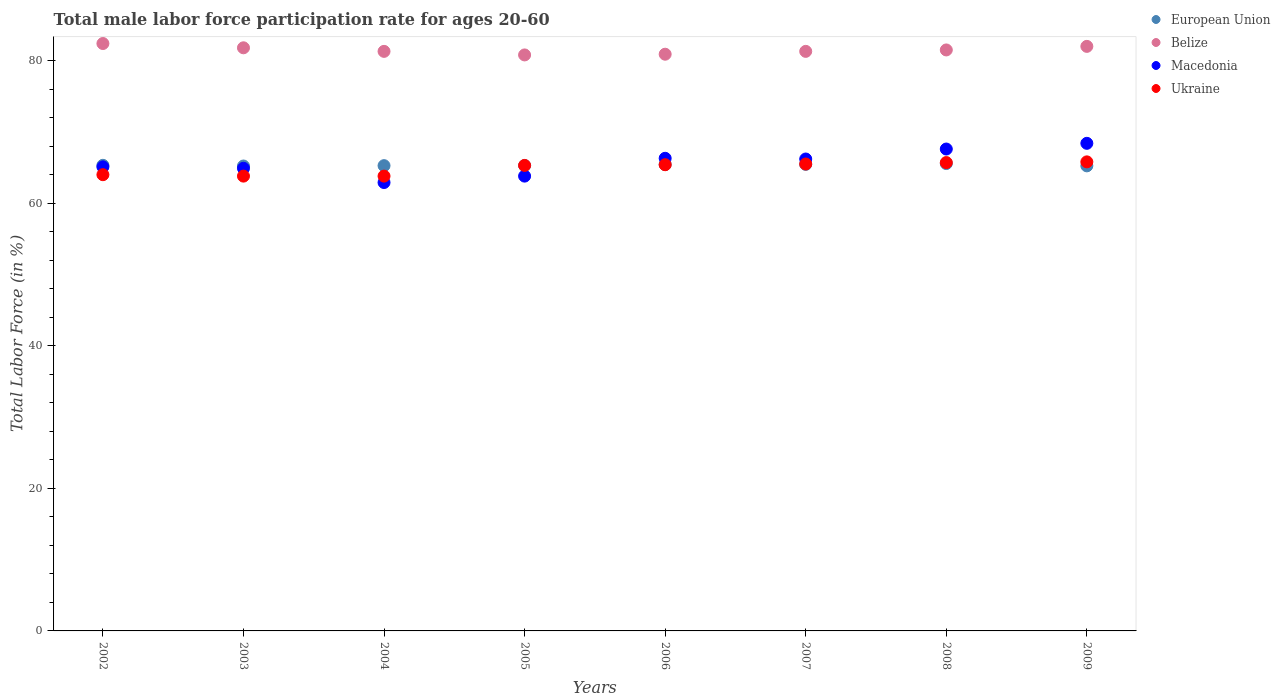How many different coloured dotlines are there?
Ensure brevity in your answer.  4. Is the number of dotlines equal to the number of legend labels?
Provide a succinct answer. Yes. What is the male labor force participation rate in Ukraine in 2007?
Your answer should be compact. 65.5. Across all years, what is the maximum male labor force participation rate in European Union?
Ensure brevity in your answer.  65.56. Across all years, what is the minimum male labor force participation rate in European Union?
Offer a terse response. 65.22. In which year was the male labor force participation rate in Ukraine maximum?
Provide a succinct answer. 2009. What is the total male labor force participation rate in Belize in the graph?
Provide a succinct answer. 652. What is the difference between the male labor force participation rate in European Union in 2002 and that in 2006?
Your answer should be compact. -0.1. What is the difference between the male labor force participation rate in Belize in 2004 and the male labor force participation rate in European Union in 2008?
Offer a very short reply. 15.74. What is the average male labor force participation rate in European Union per year?
Your answer should be compact. 65.34. In the year 2003, what is the difference between the male labor force participation rate in Macedonia and male labor force participation rate in Ukraine?
Your answer should be compact. 1.1. In how many years, is the male labor force participation rate in Macedonia greater than 8 %?
Keep it short and to the point. 8. What is the ratio of the male labor force participation rate in European Union in 2007 to that in 2008?
Ensure brevity in your answer.  1. Is the male labor force participation rate in Macedonia in 2006 less than that in 2008?
Make the answer very short. Yes. What is the difference between the highest and the second highest male labor force participation rate in Belize?
Your response must be concise. 0.4. What is the difference between the highest and the lowest male labor force participation rate in Ukraine?
Make the answer very short. 2. Is the sum of the male labor force participation rate in Ukraine in 2007 and 2009 greater than the maximum male labor force participation rate in Macedonia across all years?
Keep it short and to the point. Yes. Is it the case that in every year, the sum of the male labor force participation rate in European Union and male labor force participation rate in Belize  is greater than the sum of male labor force participation rate in Macedonia and male labor force participation rate in Ukraine?
Offer a terse response. Yes. Does the male labor force participation rate in Ukraine monotonically increase over the years?
Your response must be concise. No. How many dotlines are there?
Your answer should be very brief. 4. What is the difference between two consecutive major ticks on the Y-axis?
Provide a short and direct response. 20. Are the values on the major ticks of Y-axis written in scientific E-notation?
Your answer should be very brief. No. Does the graph contain any zero values?
Your answer should be very brief. No. Does the graph contain grids?
Your response must be concise. No. Where does the legend appear in the graph?
Your answer should be very brief. Top right. What is the title of the graph?
Offer a very short reply. Total male labor force participation rate for ages 20-60. Does "Arab World" appear as one of the legend labels in the graph?
Your response must be concise. No. What is the Total Labor Force (in %) of European Union in 2002?
Keep it short and to the point. 65.31. What is the Total Labor Force (in %) of Belize in 2002?
Make the answer very short. 82.4. What is the Total Labor Force (in %) of Macedonia in 2002?
Make the answer very short. 65.1. What is the Total Labor Force (in %) in Ukraine in 2002?
Make the answer very short. 64. What is the Total Labor Force (in %) of European Union in 2003?
Ensure brevity in your answer.  65.22. What is the Total Labor Force (in %) of Belize in 2003?
Provide a succinct answer. 81.8. What is the Total Labor Force (in %) of Macedonia in 2003?
Offer a very short reply. 64.9. What is the Total Labor Force (in %) in Ukraine in 2003?
Offer a very short reply. 63.8. What is the Total Labor Force (in %) of European Union in 2004?
Provide a short and direct response. 65.27. What is the Total Labor Force (in %) of Belize in 2004?
Offer a very short reply. 81.3. What is the Total Labor Force (in %) of Macedonia in 2004?
Your answer should be very brief. 62.9. What is the Total Labor Force (in %) of Ukraine in 2004?
Your answer should be very brief. 63.8. What is the Total Labor Force (in %) of European Union in 2005?
Offer a terse response. 65.28. What is the Total Labor Force (in %) of Belize in 2005?
Give a very brief answer. 80.8. What is the Total Labor Force (in %) of Macedonia in 2005?
Offer a very short reply. 63.8. What is the Total Labor Force (in %) in Ukraine in 2005?
Make the answer very short. 65.3. What is the Total Labor Force (in %) of European Union in 2006?
Ensure brevity in your answer.  65.42. What is the Total Labor Force (in %) of Belize in 2006?
Provide a succinct answer. 80.9. What is the Total Labor Force (in %) in Macedonia in 2006?
Offer a terse response. 66.3. What is the Total Labor Force (in %) of Ukraine in 2006?
Your answer should be compact. 65.4. What is the Total Labor Force (in %) in European Union in 2007?
Provide a succinct answer. 65.45. What is the Total Labor Force (in %) of Belize in 2007?
Your answer should be compact. 81.3. What is the Total Labor Force (in %) in Macedonia in 2007?
Provide a short and direct response. 66.2. What is the Total Labor Force (in %) of Ukraine in 2007?
Provide a short and direct response. 65.5. What is the Total Labor Force (in %) in European Union in 2008?
Ensure brevity in your answer.  65.56. What is the Total Labor Force (in %) in Belize in 2008?
Make the answer very short. 81.5. What is the Total Labor Force (in %) of Macedonia in 2008?
Make the answer very short. 67.6. What is the Total Labor Force (in %) of Ukraine in 2008?
Give a very brief answer. 65.7. What is the Total Labor Force (in %) in European Union in 2009?
Keep it short and to the point. 65.24. What is the Total Labor Force (in %) of Macedonia in 2009?
Your answer should be very brief. 68.4. What is the Total Labor Force (in %) in Ukraine in 2009?
Give a very brief answer. 65.8. Across all years, what is the maximum Total Labor Force (in %) in European Union?
Provide a short and direct response. 65.56. Across all years, what is the maximum Total Labor Force (in %) of Belize?
Your answer should be compact. 82.4. Across all years, what is the maximum Total Labor Force (in %) of Macedonia?
Give a very brief answer. 68.4. Across all years, what is the maximum Total Labor Force (in %) in Ukraine?
Provide a short and direct response. 65.8. Across all years, what is the minimum Total Labor Force (in %) of European Union?
Provide a succinct answer. 65.22. Across all years, what is the minimum Total Labor Force (in %) of Belize?
Make the answer very short. 80.8. Across all years, what is the minimum Total Labor Force (in %) in Macedonia?
Offer a terse response. 62.9. Across all years, what is the minimum Total Labor Force (in %) in Ukraine?
Give a very brief answer. 63.8. What is the total Total Labor Force (in %) in European Union in the graph?
Keep it short and to the point. 522.75. What is the total Total Labor Force (in %) in Belize in the graph?
Your answer should be very brief. 652. What is the total Total Labor Force (in %) in Macedonia in the graph?
Offer a terse response. 525.2. What is the total Total Labor Force (in %) in Ukraine in the graph?
Your answer should be very brief. 519.3. What is the difference between the Total Labor Force (in %) of European Union in 2002 and that in 2003?
Give a very brief answer. 0.1. What is the difference between the Total Labor Force (in %) in Belize in 2002 and that in 2003?
Your response must be concise. 0.6. What is the difference between the Total Labor Force (in %) of European Union in 2002 and that in 2004?
Ensure brevity in your answer.  0.05. What is the difference between the Total Labor Force (in %) in Macedonia in 2002 and that in 2004?
Offer a terse response. 2.2. What is the difference between the Total Labor Force (in %) in European Union in 2002 and that in 2005?
Offer a very short reply. 0.03. What is the difference between the Total Labor Force (in %) in Macedonia in 2002 and that in 2005?
Offer a terse response. 1.3. What is the difference between the Total Labor Force (in %) in Ukraine in 2002 and that in 2005?
Offer a very short reply. -1.3. What is the difference between the Total Labor Force (in %) in European Union in 2002 and that in 2006?
Provide a succinct answer. -0.1. What is the difference between the Total Labor Force (in %) in Belize in 2002 and that in 2006?
Your answer should be compact. 1.5. What is the difference between the Total Labor Force (in %) in Macedonia in 2002 and that in 2006?
Offer a very short reply. -1.2. What is the difference between the Total Labor Force (in %) in European Union in 2002 and that in 2007?
Offer a very short reply. -0.13. What is the difference between the Total Labor Force (in %) in Belize in 2002 and that in 2007?
Offer a terse response. 1.1. What is the difference between the Total Labor Force (in %) of Ukraine in 2002 and that in 2007?
Keep it short and to the point. -1.5. What is the difference between the Total Labor Force (in %) of European Union in 2002 and that in 2008?
Keep it short and to the point. -0.25. What is the difference between the Total Labor Force (in %) of Belize in 2002 and that in 2008?
Provide a short and direct response. 0.9. What is the difference between the Total Labor Force (in %) in Macedonia in 2002 and that in 2008?
Provide a short and direct response. -2.5. What is the difference between the Total Labor Force (in %) of Ukraine in 2002 and that in 2008?
Provide a succinct answer. -1.7. What is the difference between the Total Labor Force (in %) of European Union in 2002 and that in 2009?
Give a very brief answer. 0.08. What is the difference between the Total Labor Force (in %) in Belize in 2002 and that in 2009?
Provide a short and direct response. 0.4. What is the difference between the Total Labor Force (in %) in European Union in 2003 and that in 2004?
Provide a succinct answer. -0.05. What is the difference between the Total Labor Force (in %) of Belize in 2003 and that in 2004?
Keep it short and to the point. 0.5. What is the difference between the Total Labor Force (in %) in Macedonia in 2003 and that in 2004?
Keep it short and to the point. 2. What is the difference between the Total Labor Force (in %) in Ukraine in 2003 and that in 2004?
Ensure brevity in your answer.  0. What is the difference between the Total Labor Force (in %) of European Union in 2003 and that in 2005?
Keep it short and to the point. -0.06. What is the difference between the Total Labor Force (in %) in Ukraine in 2003 and that in 2005?
Your response must be concise. -1.5. What is the difference between the Total Labor Force (in %) of European Union in 2003 and that in 2006?
Give a very brief answer. -0.2. What is the difference between the Total Labor Force (in %) of Belize in 2003 and that in 2006?
Provide a succinct answer. 0.9. What is the difference between the Total Labor Force (in %) in Macedonia in 2003 and that in 2006?
Provide a succinct answer. -1.4. What is the difference between the Total Labor Force (in %) of European Union in 2003 and that in 2007?
Keep it short and to the point. -0.23. What is the difference between the Total Labor Force (in %) in Macedonia in 2003 and that in 2007?
Your answer should be very brief. -1.3. What is the difference between the Total Labor Force (in %) in Ukraine in 2003 and that in 2007?
Your answer should be very brief. -1.7. What is the difference between the Total Labor Force (in %) in European Union in 2003 and that in 2008?
Provide a short and direct response. -0.34. What is the difference between the Total Labor Force (in %) of Macedonia in 2003 and that in 2008?
Keep it short and to the point. -2.7. What is the difference between the Total Labor Force (in %) in Ukraine in 2003 and that in 2008?
Your answer should be very brief. -1.9. What is the difference between the Total Labor Force (in %) in European Union in 2003 and that in 2009?
Offer a very short reply. -0.02. What is the difference between the Total Labor Force (in %) of Ukraine in 2003 and that in 2009?
Make the answer very short. -2. What is the difference between the Total Labor Force (in %) of European Union in 2004 and that in 2005?
Ensure brevity in your answer.  -0.01. What is the difference between the Total Labor Force (in %) in Macedonia in 2004 and that in 2005?
Give a very brief answer. -0.9. What is the difference between the Total Labor Force (in %) of European Union in 2004 and that in 2006?
Ensure brevity in your answer.  -0.15. What is the difference between the Total Labor Force (in %) of Macedonia in 2004 and that in 2006?
Offer a very short reply. -3.4. What is the difference between the Total Labor Force (in %) in Ukraine in 2004 and that in 2006?
Offer a terse response. -1.6. What is the difference between the Total Labor Force (in %) of European Union in 2004 and that in 2007?
Keep it short and to the point. -0.18. What is the difference between the Total Labor Force (in %) in Belize in 2004 and that in 2007?
Provide a succinct answer. 0. What is the difference between the Total Labor Force (in %) of European Union in 2004 and that in 2008?
Provide a short and direct response. -0.29. What is the difference between the Total Labor Force (in %) of Belize in 2004 and that in 2008?
Ensure brevity in your answer.  -0.2. What is the difference between the Total Labor Force (in %) in European Union in 2004 and that in 2009?
Make the answer very short. 0.03. What is the difference between the Total Labor Force (in %) of Belize in 2004 and that in 2009?
Provide a short and direct response. -0.7. What is the difference between the Total Labor Force (in %) of Ukraine in 2004 and that in 2009?
Your answer should be compact. -2. What is the difference between the Total Labor Force (in %) of European Union in 2005 and that in 2006?
Offer a terse response. -0.14. What is the difference between the Total Labor Force (in %) in Belize in 2005 and that in 2006?
Your response must be concise. -0.1. What is the difference between the Total Labor Force (in %) in Macedonia in 2005 and that in 2006?
Your response must be concise. -2.5. What is the difference between the Total Labor Force (in %) in European Union in 2005 and that in 2007?
Offer a very short reply. -0.17. What is the difference between the Total Labor Force (in %) in Belize in 2005 and that in 2007?
Keep it short and to the point. -0.5. What is the difference between the Total Labor Force (in %) in European Union in 2005 and that in 2008?
Offer a very short reply. -0.28. What is the difference between the Total Labor Force (in %) in Belize in 2005 and that in 2008?
Provide a succinct answer. -0.7. What is the difference between the Total Labor Force (in %) in European Union in 2005 and that in 2009?
Give a very brief answer. 0.04. What is the difference between the Total Labor Force (in %) of Ukraine in 2005 and that in 2009?
Ensure brevity in your answer.  -0.5. What is the difference between the Total Labor Force (in %) of European Union in 2006 and that in 2007?
Keep it short and to the point. -0.03. What is the difference between the Total Labor Force (in %) in Macedonia in 2006 and that in 2007?
Offer a very short reply. 0.1. What is the difference between the Total Labor Force (in %) of European Union in 2006 and that in 2008?
Offer a terse response. -0.14. What is the difference between the Total Labor Force (in %) in Belize in 2006 and that in 2008?
Your response must be concise. -0.6. What is the difference between the Total Labor Force (in %) in Ukraine in 2006 and that in 2008?
Your answer should be compact. -0.3. What is the difference between the Total Labor Force (in %) in European Union in 2006 and that in 2009?
Ensure brevity in your answer.  0.18. What is the difference between the Total Labor Force (in %) of Belize in 2006 and that in 2009?
Provide a short and direct response. -1.1. What is the difference between the Total Labor Force (in %) of European Union in 2007 and that in 2008?
Offer a very short reply. -0.12. What is the difference between the Total Labor Force (in %) in Belize in 2007 and that in 2008?
Offer a very short reply. -0.2. What is the difference between the Total Labor Force (in %) of European Union in 2007 and that in 2009?
Provide a succinct answer. 0.21. What is the difference between the Total Labor Force (in %) in Belize in 2007 and that in 2009?
Make the answer very short. -0.7. What is the difference between the Total Labor Force (in %) of Macedonia in 2007 and that in 2009?
Offer a terse response. -2.2. What is the difference between the Total Labor Force (in %) of European Union in 2008 and that in 2009?
Your answer should be compact. 0.32. What is the difference between the Total Labor Force (in %) in Belize in 2008 and that in 2009?
Ensure brevity in your answer.  -0.5. What is the difference between the Total Labor Force (in %) of Macedonia in 2008 and that in 2009?
Ensure brevity in your answer.  -0.8. What is the difference between the Total Labor Force (in %) in Ukraine in 2008 and that in 2009?
Offer a terse response. -0.1. What is the difference between the Total Labor Force (in %) of European Union in 2002 and the Total Labor Force (in %) of Belize in 2003?
Your answer should be compact. -16.49. What is the difference between the Total Labor Force (in %) in European Union in 2002 and the Total Labor Force (in %) in Macedonia in 2003?
Keep it short and to the point. 0.41. What is the difference between the Total Labor Force (in %) in European Union in 2002 and the Total Labor Force (in %) in Ukraine in 2003?
Offer a very short reply. 1.51. What is the difference between the Total Labor Force (in %) in Belize in 2002 and the Total Labor Force (in %) in Macedonia in 2003?
Make the answer very short. 17.5. What is the difference between the Total Labor Force (in %) in Macedonia in 2002 and the Total Labor Force (in %) in Ukraine in 2003?
Provide a succinct answer. 1.3. What is the difference between the Total Labor Force (in %) of European Union in 2002 and the Total Labor Force (in %) of Belize in 2004?
Ensure brevity in your answer.  -15.99. What is the difference between the Total Labor Force (in %) in European Union in 2002 and the Total Labor Force (in %) in Macedonia in 2004?
Your answer should be very brief. 2.41. What is the difference between the Total Labor Force (in %) of European Union in 2002 and the Total Labor Force (in %) of Ukraine in 2004?
Provide a succinct answer. 1.51. What is the difference between the Total Labor Force (in %) in European Union in 2002 and the Total Labor Force (in %) in Belize in 2005?
Your response must be concise. -15.49. What is the difference between the Total Labor Force (in %) in European Union in 2002 and the Total Labor Force (in %) in Macedonia in 2005?
Give a very brief answer. 1.51. What is the difference between the Total Labor Force (in %) of European Union in 2002 and the Total Labor Force (in %) of Ukraine in 2005?
Provide a short and direct response. 0.01. What is the difference between the Total Labor Force (in %) of Belize in 2002 and the Total Labor Force (in %) of Macedonia in 2005?
Give a very brief answer. 18.6. What is the difference between the Total Labor Force (in %) of Belize in 2002 and the Total Labor Force (in %) of Ukraine in 2005?
Provide a succinct answer. 17.1. What is the difference between the Total Labor Force (in %) in European Union in 2002 and the Total Labor Force (in %) in Belize in 2006?
Offer a very short reply. -15.59. What is the difference between the Total Labor Force (in %) in European Union in 2002 and the Total Labor Force (in %) in Macedonia in 2006?
Give a very brief answer. -0.99. What is the difference between the Total Labor Force (in %) in European Union in 2002 and the Total Labor Force (in %) in Ukraine in 2006?
Make the answer very short. -0.09. What is the difference between the Total Labor Force (in %) of Belize in 2002 and the Total Labor Force (in %) of Macedonia in 2006?
Offer a terse response. 16.1. What is the difference between the Total Labor Force (in %) in Belize in 2002 and the Total Labor Force (in %) in Ukraine in 2006?
Offer a terse response. 17. What is the difference between the Total Labor Force (in %) in European Union in 2002 and the Total Labor Force (in %) in Belize in 2007?
Ensure brevity in your answer.  -15.99. What is the difference between the Total Labor Force (in %) of European Union in 2002 and the Total Labor Force (in %) of Macedonia in 2007?
Give a very brief answer. -0.89. What is the difference between the Total Labor Force (in %) of European Union in 2002 and the Total Labor Force (in %) of Ukraine in 2007?
Your answer should be very brief. -0.19. What is the difference between the Total Labor Force (in %) in Belize in 2002 and the Total Labor Force (in %) in Ukraine in 2007?
Keep it short and to the point. 16.9. What is the difference between the Total Labor Force (in %) in European Union in 2002 and the Total Labor Force (in %) in Belize in 2008?
Your response must be concise. -16.19. What is the difference between the Total Labor Force (in %) of European Union in 2002 and the Total Labor Force (in %) of Macedonia in 2008?
Make the answer very short. -2.29. What is the difference between the Total Labor Force (in %) in European Union in 2002 and the Total Labor Force (in %) in Ukraine in 2008?
Offer a terse response. -0.39. What is the difference between the Total Labor Force (in %) in European Union in 2002 and the Total Labor Force (in %) in Belize in 2009?
Make the answer very short. -16.69. What is the difference between the Total Labor Force (in %) in European Union in 2002 and the Total Labor Force (in %) in Macedonia in 2009?
Keep it short and to the point. -3.09. What is the difference between the Total Labor Force (in %) of European Union in 2002 and the Total Labor Force (in %) of Ukraine in 2009?
Offer a very short reply. -0.49. What is the difference between the Total Labor Force (in %) of Belize in 2002 and the Total Labor Force (in %) of Macedonia in 2009?
Your answer should be compact. 14. What is the difference between the Total Labor Force (in %) of Belize in 2002 and the Total Labor Force (in %) of Ukraine in 2009?
Your response must be concise. 16.6. What is the difference between the Total Labor Force (in %) of European Union in 2003 and the Total Labor Force (in %) of Belize in 2004?
Offer a terse response. -16.08. What is the difference between the Total Labor Force (in %) of European Union in 2003 and the Total Labor Force (in %) of Macedonia in 2004?
Offer a very short reply. 2.32. What is the difference between the Total Labor Force (in %) in European Union in 2003 and the Total Labor Force (in %) in Ukraine in 2004?
Make the answer very short. 1.42. What is the difference between the Total Labor Force (in %) of Belize in 2003 and the Total Labor Force (in %) of Macedonia in 2004?
Provide a short and direct response. 18.9. What is the difference between the Total Labor Force (in %) of Belize in 2003 and the Total Labor Force (in %) of Ukraine in 2004?
Your answer should be very brief. 18. What is the difference between the Total Labor Force (in %) in European Union in 2003 and the Total Labor Force (in %) in Belize in 2005?
Provide a short and direct response. -15.58. What is the difference between the Total Labor Force (in %) in European Union in 2003 and the Total Labor Force (in %) in Macedonia in 2005?
Provide a succinct answer. 1.42. What is the difference between the Total Labor Force (in %) of European Union in 2003 and the Total Labor Force (in %) of Ukraine in 2005?
Keep it short and to the point. -0.08. What is the difference between the Total Labor Force (in %) of Belize in 2003 and the Total Labor Force (in %) of Macedonia in 2005?
Offer a very short reply. 18. What is the difference between the Total Labor Force (in %) in European Union in 2003 and the Total Labor Force (in %) in Belize in 2006?
Offer a very short reply. -15.68. What is the difference between the Total Labor Force (in %) in European Union in 2003 and the Total Labor Force (in %) in Macedonia in 2006?
Provide a succinct answer. -1.08. What is the difference between the Total Labor Force (in %) in European Union in 2003 and the Total Labor Force (in %) in Ukraine in 2006?
Offer a very short reply. -0.18. What is the difference between the Total Labor Force (in %) of Belize in 2003 and the Total Labor Force (in %) of Macedonia in 2006?
Provide a succinct answer. 15.5. What is the difference between the Total Labor Force (in %) in European Union in 2003 and the Total Labor Force (in %) in Belize in 2007?
Make the answer very short. -16.08. What is the difference between the Total Labor Force (in %) in European Union in 2003 and the Total Labor Force (in %) in Macedonia in 2007?
Your answer should be very brief. -0.98. What is the difference between the Total Labor Force (in %) in European Union in 2003 and the Total Labor Force (in %) in Ukraine in 2007?
Provide a succinct answer. -0.28. What is the difference between the Total Labor Force (in %) of Belize in 2003 and the Total Labor Force (in %) of Macedonia in 2007?
Ensure brevity in your answer.  15.6. What is the difference between the Total Labor Force (in %) of European Union in 2003 and the Total Labor Force (in %) of Belize in 2008?
Your response must be concise. -16.28. What is the difference between the Total Labor Force (in %) in European Union in 2003 and the Total Labor Force (in %) in Macedonia in 2008?
Provide a short and direct response. -2.38. What is the difference between the Total Labor Force (in %) of European Union in 2003 and the Total Labor Force (in %) of Ukraine in 2008?
Make the answer very short. -0.48. What is the difference between the Total Labor Force (in %) of Belize in 2003 and the Total Labor Force (in %) of Macedonia in 2008?
Provide a succinct answer. 14.2. What is the difference between the Total Labor Force (in %) in European Union in 2003 and the Total Labor Force (in %) in Belize in 2009?
Provide a succinct answer. -16.78. What is the difference between the Total Labor Force (in %) of European Union in 2003 and the Total Labor Force (in %) of Macedonia in 2009?
Offer a very short reply. -3.18. What is the difference between the Total Labor Force (in %) in European Union in 2003 and the Total Labor Force (in %) in Ukraine in 2009?
Ensure brevity in your answer.  -0.58. What is the difference between the Total Labor Force (in %) in Belize in 2003 and the Total Labor Force (in %) in Ukraine in 2009?
Your answer should be very brief. 16. What is the difference between the Total Labor Force (in %) of Macedonia in 2003 and the Total Labor Force (in %) of Ukraine in 2009?
Provide a short and direct response. -0.9. What is the difference between the Total Labor Force (in %) of European Union in 2004 and the Total Labor Force (in %) of Belize in 2005?
Give a very brief answer. -15.53. What is the difference between the Total Labor Force (in %) in European Union in 2004 and the Total Labor Force (in %) in Macedonia in 2005?
Your response must be concise. 1.47. What is the difference between the Total Labor Force (in %) of European Union in 2004 and the Total Labor Force (in %) of Ukraine in 2005?
Make the answer very short. -0.03. What is the difference between the Total Labor Force (in %) in Macedonia in 2004 and the Total Labor Force (in %) in Ukraine in 2005?
Your answer should be very brief. -2.4. What is the difference between the Total Labor Force (in %) of European Union in 2004 and the Total Labor Force (in %) of Belize in 2006?
Ensure brevity in your answer.  -15.63. What is the difference between the Total Labor Force (in %) in European Union in 2004 and the Total Labor Force (in %) in Macedonia in 2006?
Offer a very short reply. -1.03. What is the difference between the Total Labor Force (in %) of European Union in 2004 and the Total Labor Force (in %) of Ukraine in 2006?
Make the answer very short. -0.13. What is the difference between the Total Labor Force (in %) in Belize in 2004 and the Total Labor Force (in %) in Macedonia in 2006?
Give a very brief answer. 15. What is the difference between the Total Labor Force (in %) in Belize in 2004 and the Total Labor Force (in %) in Ukraine in 2006?
Ensure brevity in your answer.  15.9. What is the difference between the Total Labor Force (in %) in European Union in 2004 and the Total Labor Force (in %) in Belize in 2007?
Provide a short and direct response. -16.03. What is the difference between the Total Labor Force (in %) in European Union in 2004 and the Total Labor Force (in %) in Macedonia in 2007?
Your answer should be compact. -0.93. What is the difference between the Total Labor Force (in %) in European Union in 2004 and the Total Labor Force (in %) in Ukraine in 2007?
Keep it short and to the point. -0.23. What is the difference between the Total Labor Force (in %) of Belize in 2004 and the Total Labor Force (in %) of Macedonia in 2007?
Your answer should be very brief. 15.1. What is the difference between the Total Labor Force (in %) of Belize in 2004 and the Total Labor Force (in %) of Ukraine in 2007?
Offer a very short reply. 15.8. What is the difference between the Total Labor Force (in %) of European Union in 2004 and the Total Labor Force (in %) of Belize in 2008?
Offer a terse response. -16.23. What is the difference between the Total Labor Force (in %) in European Union in 2004 and the Total Labor Force (in %) in Macedonia in 2008?
Make the answer very short. -2.33. What is the difference between the Total Labor Force (in %) of European Union in 2004 and the Total Labor Force (in %) of Ukraine in 2008?
Your response must be concise. -0.43. What is the difference between the Total Labor Force (in %) of Belize in 2004 and the Total Labor Force (in %) of Ukraine in 2008?
Your response must be concise. 15.6. What is the difference between the Total Labor Force (in %) in Macedonia in 2004 and the Total Labor Force (in %) in Ukraine in 2008?
Provide a short and direct response. -2.8. What is the difference between the Total Labor Force (in %) in European Union in 2004 and the Total Labor Force (in %) in Belize in 2009?
Offer a terse response. -16.73. What is the difference between the Total Labor Force (in %) in European Union in 2004 and the Total Labor Force (in %) in Macedonia in 2009?
Ensure brevity in your answer.  -3.13. What is the difference between the Total Labor Force (in %) of European Union in 2004 and the Total Labor Force (in %) of Ukraine in 2009?
Your response must be concise. -0.53. What is the difference between the Total Labor Force (in %) in Belize in 2004 and the Total Labor Force (in %) in Ukraine in 2009?
Keep it short and to the point. 15.5. What is the difference between the Total Labor Force (in %) of European Union in 2005 and the Total Labor Force (in %) of Belize in 2006?
Offer a very short reply. -15.62. What is the difference between the Total Labor Force (in %) of European Union in 2005 and the Total Labor Force (in %) of Macedonia in 2006?
Give a very brief answer. -1.02. What is the difference between the Total Labor Force (in %) in European Union in 2005 and the Total Labor Force (in %) in Ukraine in 2006?
Provide a succinct answer. -0.12. What is the difference between the Total Labor Force (in %) in Belize in 2005 and the Total Labor Force (in %) in Ukraine in 2006?
Make the answer very short. 15.4. What is the difference between the Total Labor Force (in %) in Macedonia in 2005 and the Total Labor Force (in %) in Ukraine in 2006?
Your answer should be compact. -1.6. What is the difference between the Total Labor Force (in %) of European Union in 2005 and the Total Labor Force (in %) of Belize in 2007?
Give a very brief answer. -16.02. What is the difference between the Total Labor Force (in %) of European Union in 2005 and the Total Labor Force (in %) of Macedonia in 2007?
Provide a short and direct response. -0.92. What is the difference between the Total Labor Force (in %) of European Union in 2005 and the Total Labor Force (in %) of Ukraine in 2007?
Provide a short and direct response. -0.22. What is the difference between the Total Labor Force (in %) of Macedonia in 2005 and the Total Labor Force (in %) of Ukraine in 2007?
Offer a terse response. -1.7. What is the difference between the Total Labor Force (in %) of European Union in 2005 and the Total Labor Force (in %) of Belize in 2008?
Keep it short and to the point. -16.22. What is the difference between the Total Labor Force (in %) in European Union in 2005 and the Total Labor Force (in %) in Macedonia in 2008?
Offer a very short reply. -2.32. What is the difference between the Total Labor Force (in %) of European Union in 2005 and the Total Labor Force (in %) of Ukraine in 2008?
Provide a succinct answer. -0.42. What is the difference between the Total Labor Force (in %) in Belize in 2005 and the Total Labor Force (in %) in Macedonia in 2008?
Offer a terse response. 13.2. What is the difference between the Total Labor Force (in %) in European Union in 2005 and the Total Labor Force (in %) in Belize in 2009?
Provide a short and direct response. -16.72. What is the difference between the Total Labor Force (in %) in European Union in 2005 and the Total Labor Force (in %) in Macedonia in 2009?
Make the answer very short. -3.12. What is the difference between the Total Labor Force (in %) of European Union in 2005 and the Total Labor Force (in %) of Ukraine in 2009?
Your response must be concise. -0.52. What is the difference between the Total Labor Force (in %) in Macedonia in 2005 and the Total Labor Force (in %) in Ukraine in 2009?
Give a very brief answer. -2. What is the difference between the Total Labor Force (in %) of European Union in 2006 and the Total Labor Force (in %) of Belize in 2007?
Give a very brief answer. -15.88. What is the difference between the Total Labor Force (in %) of European Union in 2006 and the Total Labor Force (in %) of Macedonia in 2007?
Offer a terse response. -0.78. What is the difference between the Total Labor Force (in %) of European Union in 2006 and the Total Labor Force (in %) of Ukraine in 2007?
Provide a succinct answer. -0.08. What is the difference between the Total Labor Force (in %) of Belize in 2006 and the Total Labor Force (in %) of Ukraine in 2007?
Ensure brevity in your answer.  15.4. What is the difference between the Total Labor Force (in %) in European Union in 2006 and the Total Labor Force (in %) in Belize in 2008?
Offer a very short reply. -16.08. What is the difference between the Total Labor Force (in %) of European Union in 2006 and the Total Labor Force (in %) of Macedonia in 2008?
Keep it short and to the point. -2.18. What is the difference between the Total Labor Force (in %) in European Union in 2006 and the Total Labor Force (in %) in Ukraine in 2008?
Offer a very short reply. -0.28. What is the difference between the Total Labor Force (in %) of Belize in 2006 and the Total Labor Force (in %) of Ukraine in 2008?
Your answer should be compact. 15.2. What is the difference between the Total Labor Force (in %) in European Union in 2006 and the Total Labor Force (in %) in Belize in 2009?
Provide a short and direct response. -16.58. What is the difference between the Total Labor Force (in %) in European Union in 2006 and the Total Labor Force (in %) in Macedonia in 2009?
Ensure brevity in your answer.  -2.98. What is the difference between the Total Labor Force (in %) of European Union in 2006 and the Total Labor Force (in %) of Ukraine in 2009?
Ensure brevity in your answer.  -0.38. What is the difference between the Total Labor Force (in %) of Belize in 2006 and the Total Labor Force (in %) of Ukraine in 2009?
Give a very brief answer. 15.1. What is the difference between the Total Labor Force (in %) of European Union in 2007 and the Total Labor Force (in %) of Belize in 2008?
Offer a terse response. -16.05. What is the difference between the Total Labor Force (in %) in European Union in 2007 and the Total Labor Force (in %) in Macedonia in 2008?
Give a very brief answer. -2.15. What is the difference between the Total Labor Force (in %) of European Union in 2007 and the Total Labor Force (in %) of Ukraine in 2008?
Make the answer very short. -0.25. What is the difference between the Total Labor Force (in %) in Belize in 2007 and the Total Labor Force (in %) in Ukraine in 2008?
Give a very brief answer. 15.6. What is the difference between the Total Labor Force (in %) in European Union in 2007 and the Total Labor Force (in %) in Belize in 2009?
Provide a succinct answer. -16.55. What is the difference between the Total Labor Force (in %) in European Union in 2007 and the Total Labor Force (in %) in Macedonia in 2009?
Your answer should be very brief. -2.95. What is the difference between the Total Labor Force (in %) in European Union in 2007 and the Total Labor Force (in %) in Ukraine in 2009?
Make the answer very short. -0.35. What is the difference between the Total Labor Force (in %) of Belize in 2007 and the Total Labor Force (in %) of Ukraine in 2009?
Ensure brevity in your answer.  15.5. What is the difference between the Total Labor Force (in %) of Macedonia in 2007 and the Total Labor Force (in %) of Ukraine in 2009?
Offer a terse response. 0.4. What is the difference between the Total Labor Force (in %) in European Union in 2008 and the Total Labor Force (in %) in Belize in 2009?
Your answer should be compact. -16.44. What is the difference between the Total Labor Force (in %) of European Union in 2008 and the Total Labor Force (in %) of Macedonia in 2009?
Offer a very short reply. -2.84. What is the difference between the Total Labor Force (in %) in European Union in 2008 and the Total Labor Force (in %) in Ukraine in 2009?
Your answer should be very brief. -0.24. What is the difference between the Total Labor Force (in %) of Macedonia in 2008 and the Total Labor Force (in %) of Ukraine in 2009?
Your answer should be very brief. 1.8. What is the average Total Labor Force (in %) in European Union per year?
Make the answer very short. 65.34. What is the average Total Labor Force (in %) in Belize per year?
Provide a succinct answer. 81.5. What is the average Total Labor Force (in %) in Macedonia per year?
Give a very brief answer. 65.65. What is the average Total Labor Force (in %) of Ukraine per year?
Your answer should be compact. 64.91. In the year 2002, what is the difference between the Total Labor Force (in %) of European Union and Total Labor Force (in %) of Belize?
Your response must be concise. -17.09. In the year 2002, what is the difference between the Total Labor Force (in %) of European Union and Total Labor Force (in %) of Macedonia?
Offer a terse response. 0.21. In the year 2002, what is the difference between the Total Labor Force (in %) in European Union and Total Labor Force (in %) in Ukraine?
Your answer should be very brief. 1.31. In the year 2002, what is the difference between the Total Labor Force (in %) in Belize and Total Labor Force (in %) in Macedonia?
Your answer should be compact. 17.3. In the year 2002, what is the difference between the Total Labor Force (in %) of Belize and Total Labor Force (in %) of Ukraine?
Your answer should be compact. 18.4. In the year 2002, what is the difference between the Total Labor Force (in %) in Macedonia and Total Labor Force (in %) in Ukraine?
Keep it short and to the point. 1.1. In the year 2003, what is the difference between the Total Labor Force (in %) in European Union and Total Labor Force (in %) in Belize?
Your response must be concise. -16.58. In the year 2003, what is the difference between the Total Labor Force (in %) of European Union and Total Labor Force (in %) of Macedonia?
Ensure brevity in your answer.  0.32. In the year 2003, what is the difference between the Total Labor Force (in %) of European Union and Total Labor Force (in %) of Ukraine?
Ensure brevity in your answer.  1.42. In the year 2004, what is the difference between the Total Labor Force (in %) in European Union and Total Labor Force (in %) in Belize?
Provide a succinct answer. -16.03. In the year 2004, what is the difference between the Total Labor Force (in %) in European Union and Total Labor Force (in %) in Macedonia?
Provide a short and direct response. 2.37. In the year 2004, what is the difference between the Total Labor Force (in %) of European Union and Total Labor Force (in %) of Ukraine?
Your answer should be very brief. 1.47. In the year 2004, what is the difference between the Total Labor Force (in %) of Macedonia and Total Labor Force (in %) of Ukraine?
Keep it short and to the point. -0.9. In the year 2005, what is the difference between the Total Labor Force (in %) in European Union and Total Labor Force (in %) in Belize?
Keep it short and to the point. -15.52. In the year 2005, what is the difference between the Total Labor Force (in %) in European Union and Total Labor Force (in %) in Macedonia?
Give a very brief answer. 1.48. In the year 2005, what is the difference between the Total Labor Force (in %) of European Union and Total Labor Force (in %) of Ukraine?
Provide a short and direct response. -0.02. In the year 2005, what is the difference between the Total Labor Force (in %) in Belize and Total Labor Force (in %) in Macedonia?
Your response must be concise. 17. In the year 2005, what is the difference between the Total Labor Force (in %) in Macedonia and Total Labor Force (in %) in Ukraine?
Your answer should be compact. -1.5. In the year 2006, what is the difference between the Total Labor Force (in %) of European Union and Total Labor Force (in %) of Belize?
Ensure brevity in your answer.  -15.48. In the year 2006, what is the difference between the Total Labor Force (in %) in European Union and Total Labor Force (in %) in Macedonia?
Provide a succinct answer. -0.88. In the year 2006, what is the difference between the Total Labor Force (in %) in European Union and Total Labor Force (in %) in Ukraine?
Keep it short and to the point. 0.02. In the year 2006, what is the difference between the Total Labor Force (in %) in Macedonia and Total Labor Force (in %) in Ukraine?
Your answer should be very brief. 0.9. In the year 2007, what is the difference between the Total Labor Force (in %) in European Union and Total Labor Force (in %) in Belize?
Provide a short and direct response. -15.85. In the year 2007, what is the difference between the Total Labor Force (in %) in European Union and Total Labor Force (in %) in Macedonia?
Your answer should be very brief. -0.75. In the year 2007, what is the difference between the Total Labor Force (in %) of European Union and Total Labor Force (in %) of Ukraine?
Your answer should be very brief. -0.05. In the year 2007, what is the difference between the Total Labor Force (in %) in Belize and Total Labor Force (in %) in Macedonia?
Keep it short and to the point. 15.1. In the year 2008, what is the difference between the Total Labor Force (in %) in European Union and Total Labor Force (in %) in Belize?
Make the answer very short. -15.94. In the year 2008, what is the difference between the Total Labor Force (in %) in European Union and Total Labor Force (in %) in Macedonia?
Give a very brief answer. -2.04. In the year 2008, what is the difference between the Total Labor Force (in %) of European Union and Total Labor Force (in %) of Ukraine?
Provide a short and direct response. -0.14. In the year 2008, what is the difference between the Total Labor Force (in %) in Macedonia and Total Labor Force (in %) in Ukraine?
Make the answer very short. 1.9. In the year 2009, what is the difference between the Total Labor Force (in %) in European Union and Total Labor Force (in %) in Belize?
Your answer should be very brief. -16.76. In the year 2009, what is the difference between the Total Labor Force (in %) in European Union and Total Labor Force (in %) in Macedonia?
Provide a succinct answer. -3.16. In the year 2009, what is the difference between the Total Labor Force (in %) of European Union and Total Labor Force (in %) of Ukraine?
Ensure brevity in your answer.  -0.56. What is the ratio of the Total Labor Force (in %) in Belize in 2002 to that in 2003?
Give a very brief answer. 1.01. What is the ratio of the Total Labor Force (in %) of Macedonia in 2002 to that in 2003?
Give a very brief answer. 1. What is the ratio of the Total Labor Force (in %) in Ukraine in 2002 to that in 2003?
Your answer should be compact. 1. What is the ratio of the Total Labor Force (in %) in Belize in 2002 to that in 2004?
Your answer should be compact. 1.01. What is the ratio of the Total Labor Force (in %) of Macedonia in 2002 to that in 2004?
Your answer should be compact. 1.03. What is the ratio of the Total Labor Force (in %) in Belize in 2002 to that in 2005?
Give a very brief answer. 1.02. What is the ratio of the Total Labor Force (in %) of Macedonia in 2002 to that in 2005?
Your answer should be compact. 1.02. What is the ratio of the Total Labor Force (in %) of Ukraine in 2002 to that in 2005?
Your answer should be very brief. 0.98. What is the ratio of the Total Labor Force (in %) of Belize in 2002 to that in 2006?
Give a very brief answer. 1.02. What is the ratio of the Total Labor Force (in %) of Macedonia in 2002 to that in 2006?
Your response must be concise. 0.98. What is the ratio of the Total Labor Force (in %) of Ukraine in 2002 to that in 2006?
Your response must be concise. 0.98. What is the ratio of the Total Labor Force (in %) in Belize in 2002 to that in 2007?
Offer a very short reply. 1.01. What is the ratio of the Total Labor Force (in %) of Macedonia in 2002 to that in 2007?
Give a very brief answer. 0.98. What is the ratio of the Total Labor Force (in %) of Ukraine in 2002 to that in 2007?
Your answer should be very brief. 0.98. What is the ratio of the Total Labor Force (in %) of Macedonia in 2002 to that in 2008?
Offer a terse response. 0.96. What is the ratio of the Total Labor Force (in %) of Ukraine in 2002 to that in 2008?
Ensure brevity in your answer.  0.97. What is the ratio of the Total Labor Force (in %) of Macedonia in 2002 to that in 2009?
Provide a short and direct response. 0.95. What is the ratio of the Total Labor Force (in %) in Ukraine in 2002 to that in 2009?
Keep it short and to the point. 0.97. What is the ratio of the Total Labor Force (in %) of Belize in 2003 to that in 2004?
Keep it short and to the point. 1.01. What is the ratio of the Total Labor Force (in %) of Macedonia in 2003 to that in 2004?
Your answer should be very brief. 1.03. What is the ratio of the Total Labor Force (in %) in Ukraine in 2003 to that in 2004?
Your answer should be compact. 1. What is the ratio of the Total Labor Force (in %) of European Union in 2003 to that in 2005?
Your answer should be compact. 1. What is the ratio of the Total Labor Force (in %) in Belize in 2003 to that in 2005?
Offer a terse response. 1.01. What is the ratio of the Total Labor Force (in %) in Macedonia in 2003 to that in 2005?
Ensure brevity in your answer.  1.02. What is the ratio of the Total Labor Force (in %) in Ukraine in 2003 to that in 2005?
Ensure brevity in your answer.  0.98. What is the ratio of the Total Labor Force (in %) of European Union in 2003 to that in 2006?
Provide a short and direct response. 1. What is the ratio of the Total Labor Force (in %) of Belize in 2003 to that in 2006?
Provide a succinct answer. 1.01. What is the ratio of the Total Labor Force (in %) in Macedonia in 2003 to that in 2006?
Your answer should be compact. 0.98. What is the ratio of the Total Labor Force (in %) of Ukraine in 2003 to that in 2006?
Give a very brief answer. 0.98. What is the ratio of the Total Labor Force (in %) in Macedonia in 2003 to that in 2007?
Offer a terse response. 0.98. What is the ratio of the Total Labor Force (in %) of Ukraine in 2003 to that in 2007?
Provide a succinct answer. 0.97. What is the ratio of the Total Labor Force (in %) in European Union in 2003 to that in 2008?
Your answer should be very brief. 0.99. What is the ratio of the Total Labor Force (in %) in Belize in 2003 to that in 2008?
Give a very brief answer. 1. What is the ratio of the Total Labor Force (in %) of Macedonia in 2003 to that in 2008?
Your answer should be compact. 0.96. What is the ratio of the Total Labor Force (in %) of Ukraine in 2003 to that in 2008?
Give a very brief answer. 0.97. What is the ratio of the Total Labor Force (in %) of European Union in 2003 to that in 2009?
Your response must be concise. 1. What is the ratio of the Total Labor Force (in %) of Belize in 2003 to that in 2009?
Offer a very short reply. 1. What is the ratio of the Total Labor Force (in %) in Macedonia in 2003 to that in 2009?
Your answer should be very brief. 0.95. What is the ratio of the Total Labor Force (in %) of Ukraine in 2003 to that in 2009?
Offer a terse response. 0.97. What is the ratio of the Total Labor Force (in %) of European Union in 2004 to that in 2005?
Give a very brief answer. 1. What is the ratio of the Total Labor Force (in %) of Belize in 2004 to that in 2005?
Make the answer very short. 1.01. What is the ratio of the Total Labor Force (in %) of Macedonia in 2004 to that in 2005?
Keep it short and to the point. 0.99. What is the ratio of the Total Labor Force (in %) of Ukraine in 2004 to that in 2005?
Your response must be concise. 0.98. What is the ratio of the Total Labor Force (in %) of Macedonia in 2004 to that in 2006?
Ensure brevity in your answer.  0.95. What is the ratio of the Total Labor Force (in %) in Ukraine in 2004 to that in 2006?
Keep it short and to the point. 0.98. What is the ratio of the Total Labor Force (in %) of Belize in 2004 to that in 2007?
Provide a succinct answer. 1. What is the ratio of the Total Labor Force (in %) in Macedonia in 2004 to that in 2007?
Ensure brevity in your answer.  0.95. What is the ratio of the Total Labor Force (in %) in Ukraine in 2004 to that in 2007?
Your answer should be compact. 0.97. What is the ratio of the Total Labor Force (in %) in Macedonia in 2004 to that in 2008?
Give a very brief answer. 0.93. What is the ratio of the Total Labor Force (in %) in Ukraine in 2004 to that in 2008?
Offer a very short reply. 0.97. What is the ratio of the Total Labor Force (in %) of Belize in 2004 to that in 2009?
Provide a succinct answer. 0.99. What is the ratio of the Total Labor Force (in %) in Macedonia in 2004 to that in 2009?
Your answer should be very brief. 0.92. What is the ratio of the Total Labor Force (in %) in Ukraine in 2004 to that in 2009?
Give a very brief answer. 0.97. What is the ratio of the Total Labor Force (in %) in European Union in 2005 to that in 2006?
Provide a short and direct response. 1. What is the ratio of the Total Labor Force (in %) in Belize in 2005 to that in 2006?
Offer a very short reply. 1. What is the ratio of the Total Labor Force (in %) of Macedonia in 2005 to that in 2006?
Your response must be concise. 0.96. What is the ratio of the Total Labor Force (in %) in Ukraine in 2005 to that in 2006?
Offer a very short reply. 1. What is the ratio of the Total Labor Force (in %) of European Union in 2005 to that in 2007?
Your response must be concise. 1. What is the ratio of the Total Labor Force (in %) in Macedonia in 2005 to that in 2007?
Your answer should be very brief. 0.96. What is the ratio of the Total Labor Force (in %) in Ukraine in 2005 to that in 2007?
Ensure brevity in your answer.  1. What is the ratio of the Total Labor Force (in %) of Belize in 2005 to that in 2008?
Your answer should be compact. 0.99. What is the ratio of the Total Labor Force (in %) in Macedonia in 2005 to that in 2008?
Your response must be concise. 0.94. What is the ratio of the Total Labor Force (in %) of Belize in 2005 to that in 2009?
Your answer should be very brief. 0.99. What is the ratio of the Total Labor Force (in %) in Macedonia in 2005 to that in 2009?
Your response must be concise. 0.93. What is the ratio of the Total Labor Force (in %) in Ukraine in 2005 to that in 2009?
Provide a succinct answer. 0.99. What is the ratio of the Total Labor Force (in %) in European Union in 2006 to that in 2007?
Keep it short and to the point. 1. What is the ratio of the Total Labor Force (in %) of Ukraine in 2006 to that in 2007?
Your answer should be compact. 1. What is the ratio of the Total Labor Force (in %) of Macedonia in 2006 to that in 2008?
Give a very brief answer. 0.98. What is the ratio of the Total Labor Force (in %) of Ukraine in 2006 to that in 2008?
Give a very brief answer. 1. What is the ratio of the Total Labor Force (in %) in Belize in 2006 to that in 2009?
Keep it short and to the point. 0.99. What is the ratio of the Total Labor Force (in %) of Macedonia in 2006 to that in 2009?
Your answer should be compact. 0.97. What is the ratio of the Total Labor Force (in %) in Ukraine in 2006 to that in 2009?
Your answer should be very brief. 0.99. What is the ratio of the Total Labor Force (in %) in European Union in 2007 to that in 2008?
Provide a short and direct response. 1. What is the ratio of the Total Labor Force (in %) in Macedonia in 2007 to that in 2008?
Provide a succinct answer. 0.98. What is the ratio of the Total Labor Force (in %) of Ukraine in 2007 to that in 2008?
Your answer should be very brief. 1. What is the ratio of the Total Labor Force (in %) in Belize in 2007 to that in 2009?
Your answer should be very brief. 0.99. What is the ratio of the Total Labor Force (in %) in Macedonia in 2007 to that in 2009?
Give a very brief answer. 0.97. What is the ratio of the Total Labor Force (in %) of Ukraine in 2007 to that in 2009?
Ensure brevity in your answer.  1. What is the ratio of the Total Labor Force (in %) in European Union in 2008 to that in 2009?
Offer a terse response. 1. What is the ratio of the Total Labor Force (in %) in Macedonia in 2008 to that in 2009?
Offer a terse response. 0.99. What is the difference between the highest and the second highest Total Labor Force (in %) of European Union?
Offer a terse response. 0.12. What is the difference between the highest and the lowest Total Labor Force (in %) of European Union?
Your answer should be very brief. 0.34. What is the difference between the highest and the lowest Total Labor Force (in %) in Macedonia?
Provide a succinct answer. 5.5. What is the difference between the highest and the lowest Total Labor Force (in %) of Ukraine?
Keep it short and to the point. 2. 